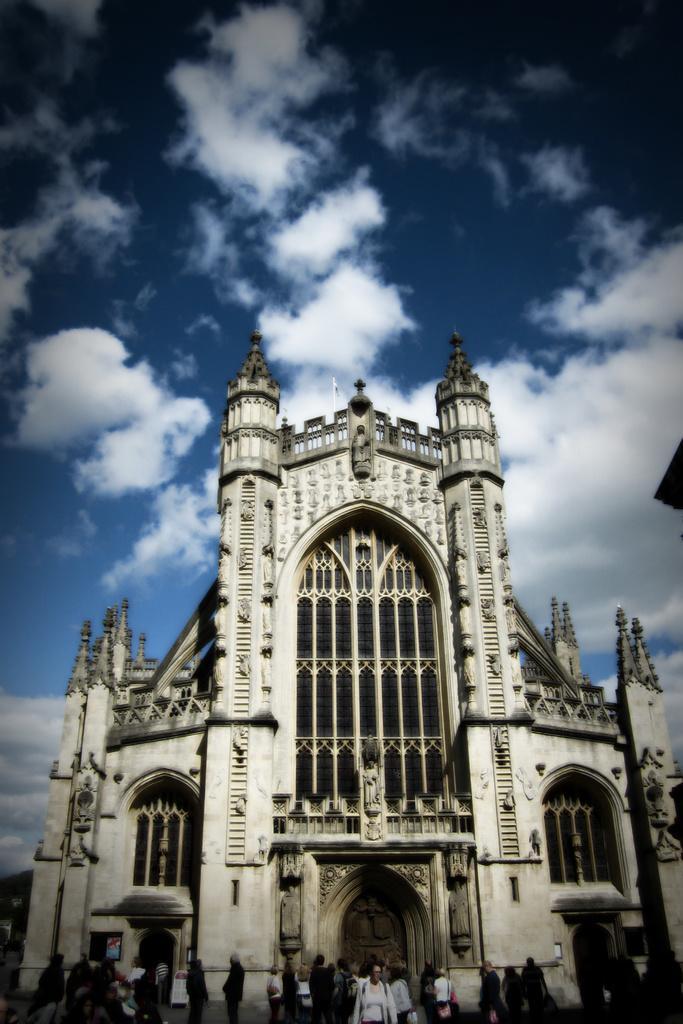Could you give a brief overview of what you see in this image? In this picture we can see there are some people standing on the path. Behind the people there is a building and the sky. 